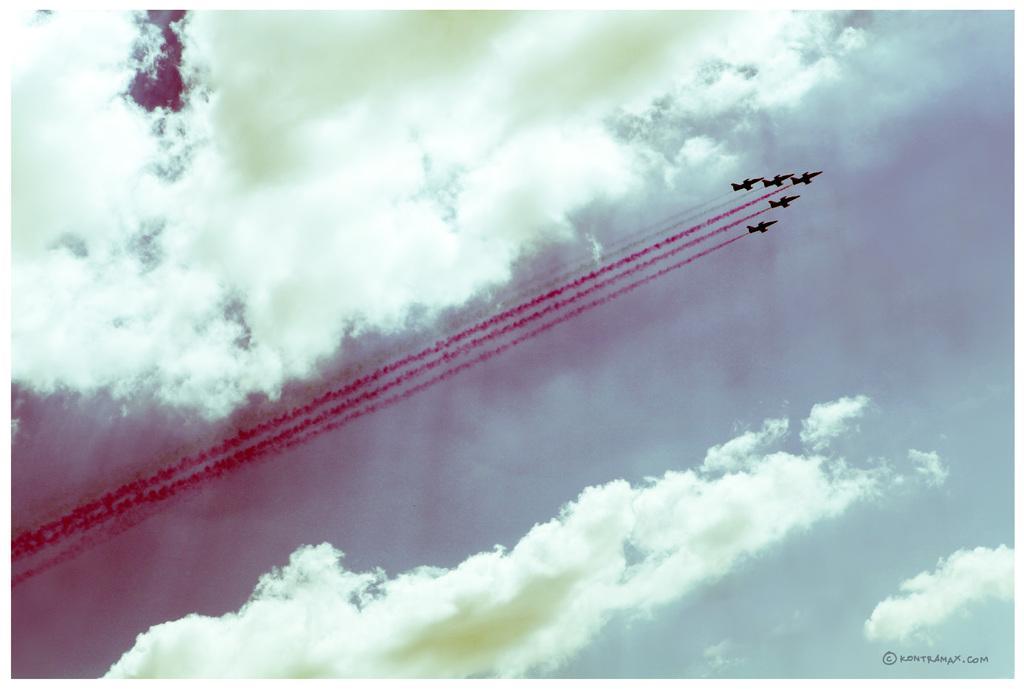Can you describe this image briefly? In this picture we can see five jet planes in the air, we can also see smoke, there is the sky and clouds in the background, we can see some text at the right bottom. 